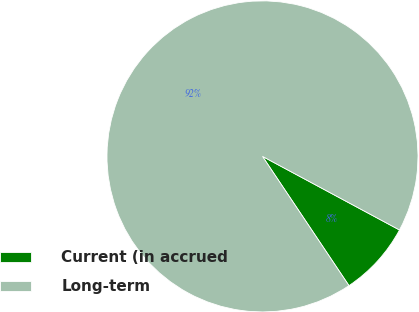<chart> <loc_0><loc_0><loc_500><loc_500><pie_chart><fcel>Current (in accrued<fcel>Long-term<nl><fcel>7.77%<fcel>92.23%<nl></chart> 